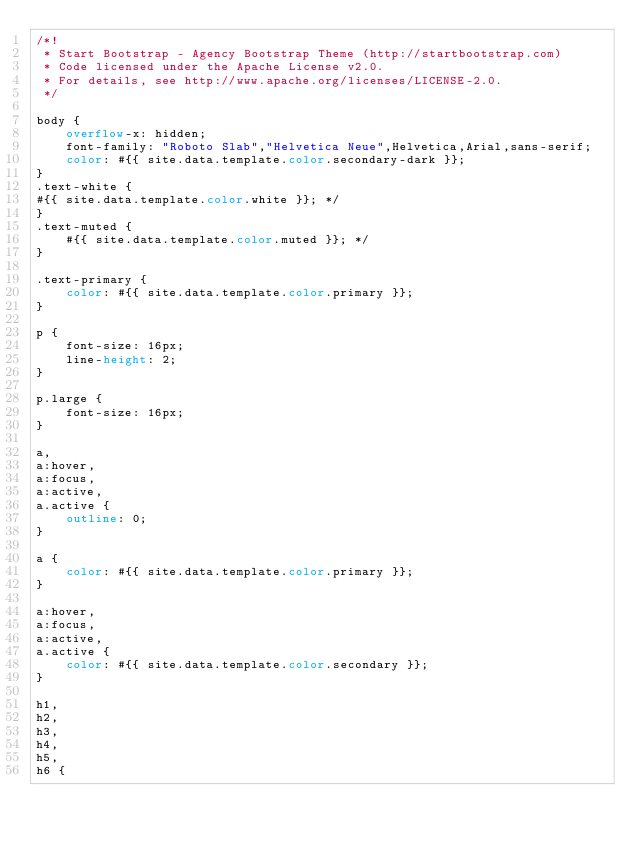<code> <loc_0><loc_0><loc_500><loc_500><_CSS_>/*!
 * Start Bootstrap - Agency Bootstrap Theme (http://startbootstrap.com)
 * Code licensed under the Apache License v2.0.
 * For details, see http://www.apache.org/licenses/LICENSE-2.0.
 */

body {
    overflow-x: hidden;
    font-family: "Roboto Slab","Helvetica Neue",Helvetica,Arial,sans-serif;
    color: #{{ site.data.template.color.secondary-dark }};
}
.text-white {
#{{ site.data.template.color.white }}; */
}
.text-muted {
    #{{ site.data.template.color.muted }}; */
}

.text-primary {
    color: #{{ site.data.template.color.primary }};
}

p {
    font-size: 16px;
    line-height: 2;
}

p.large {
    font-size: 16px;
}

a,
a:hover,
a:focus,
a:active,
a.active {
    outline: 0;
}

a {
    color: #{{ site.data.template.color.primary }};
}

a:hover,
a:focus,
a:active,
a.active {
    color: #{{ site.data.template.color.secondary }};
}

h1,
h2,
h3,
h4,
h5,
h6 {</code> 